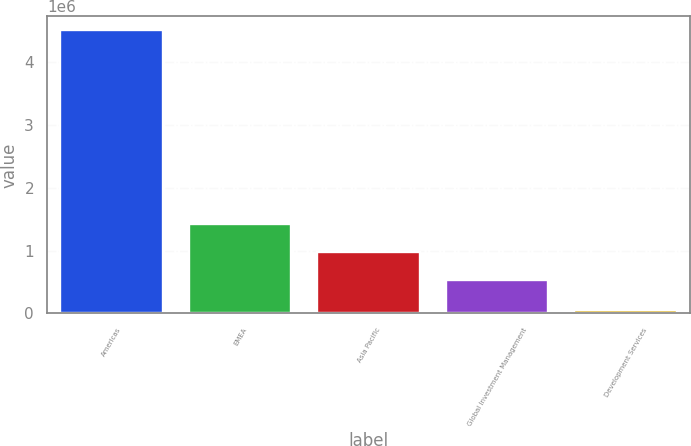Convert chart to OTSL. <chart><loc_0><loc_0><loc_500><loc_500><bar_chart><fcel>Americas<fcel>EMEA<fcel>Asia Pacific<fcel>Global Investment Management<fcel>Development Services<nl><fcel>4.50452e+06<fcel>1.42736e+06<fcel>982230<fcel>537102<fcel>53242<nl></chart> 